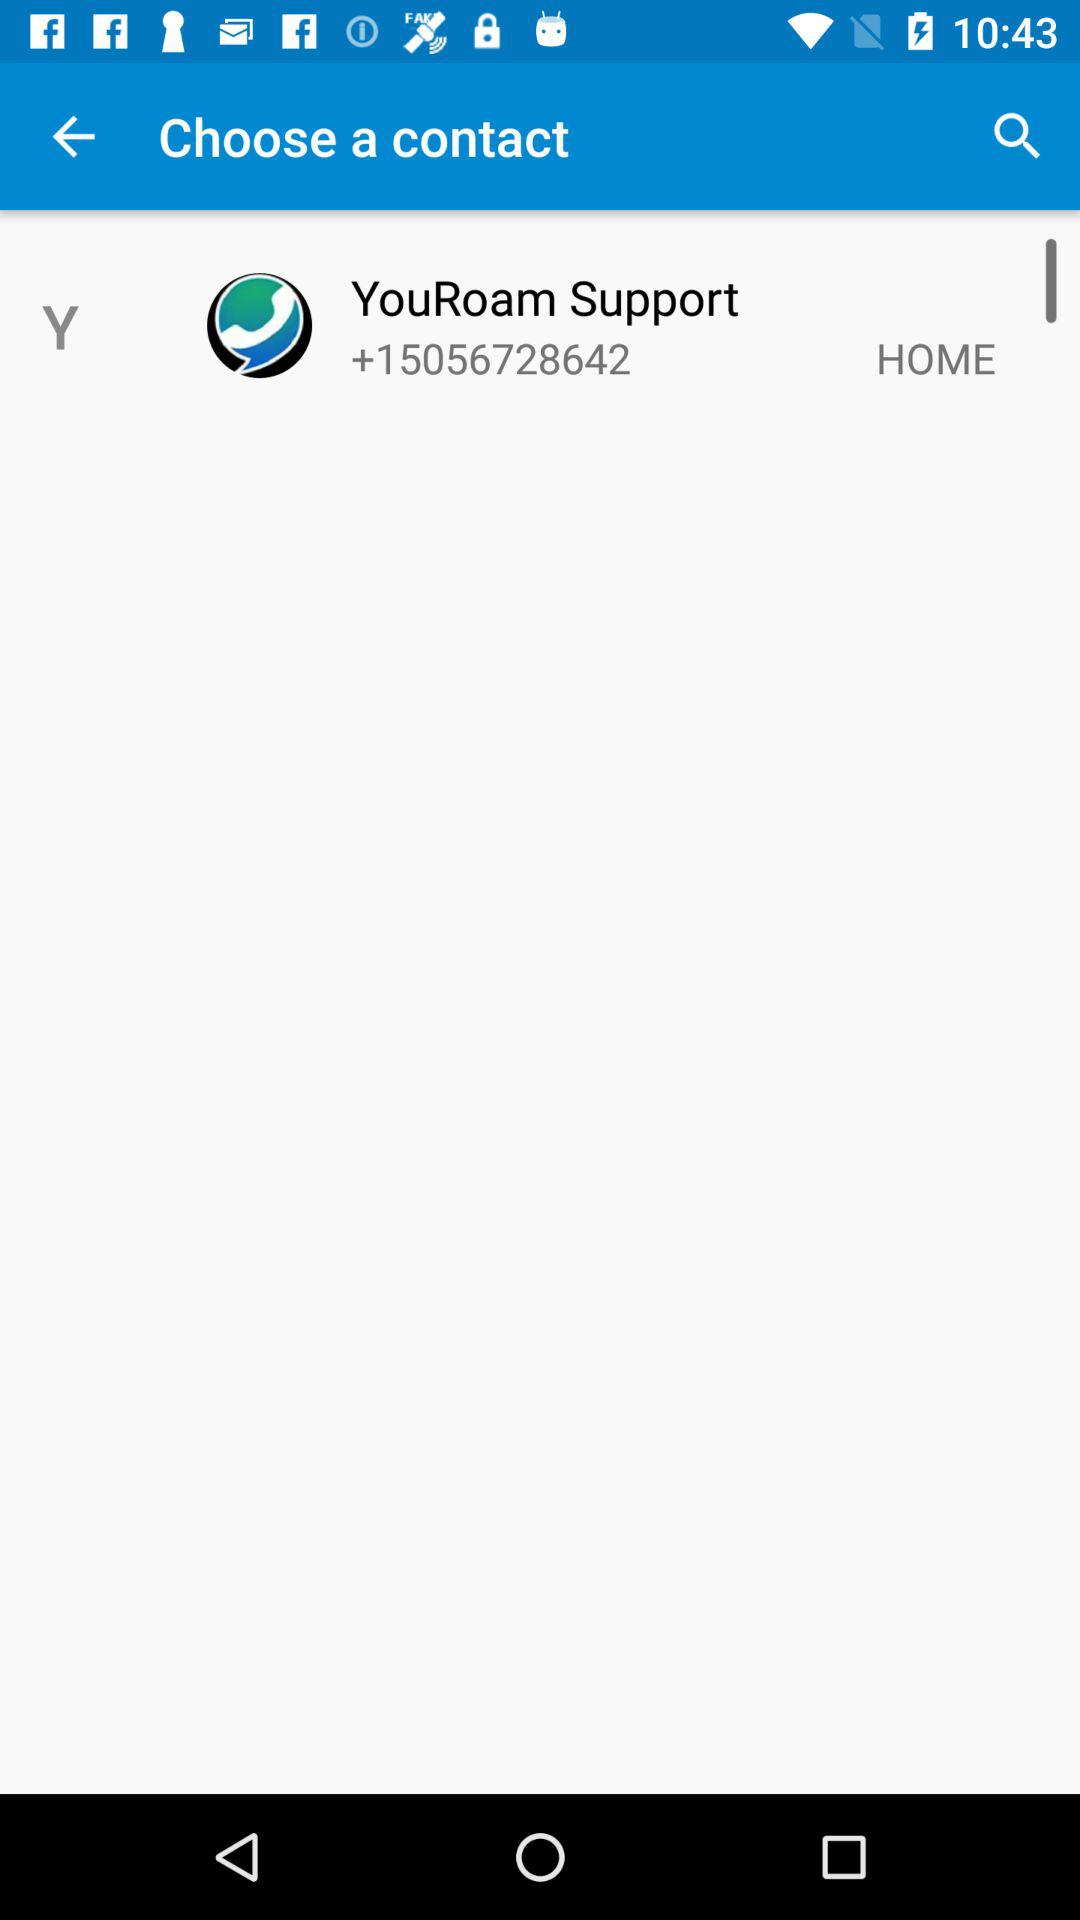What's the contact number for YouRoam Support? The contact number is +15056728642. 